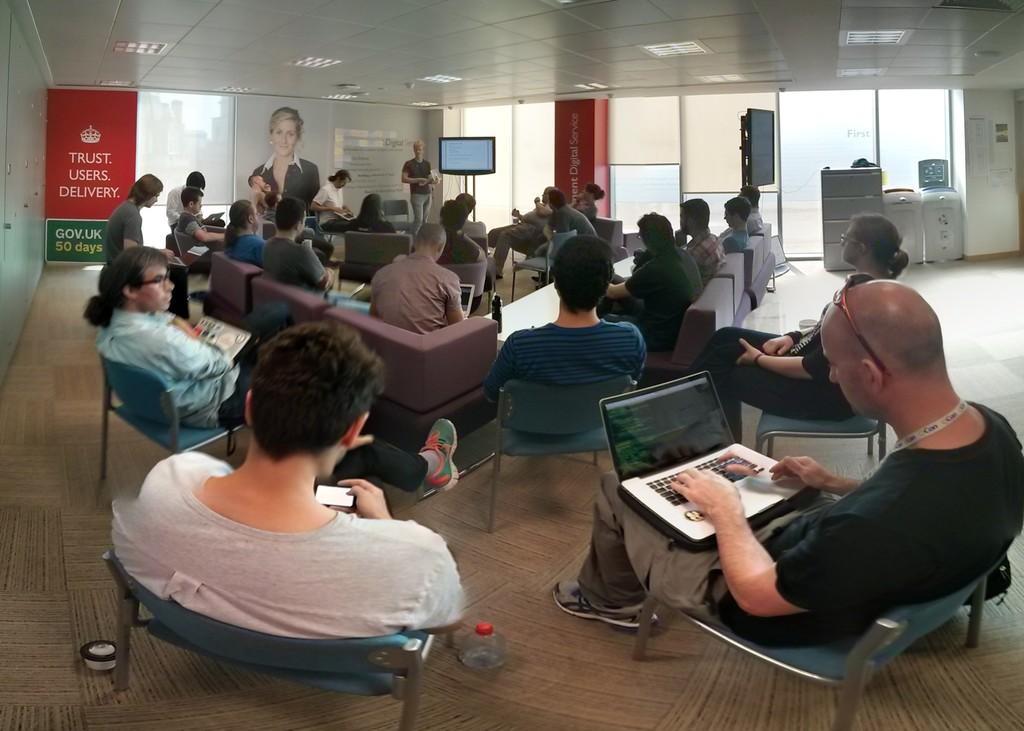Please provide a concise description of this image. This is a picture of a classroom, where there are many people attending a class, In the background there is a monitor. In the room there are many chairs, couches. In the background there are windows. On the top left there is a hoarding. In the foreground left there is a laptop on right there is mobile. 